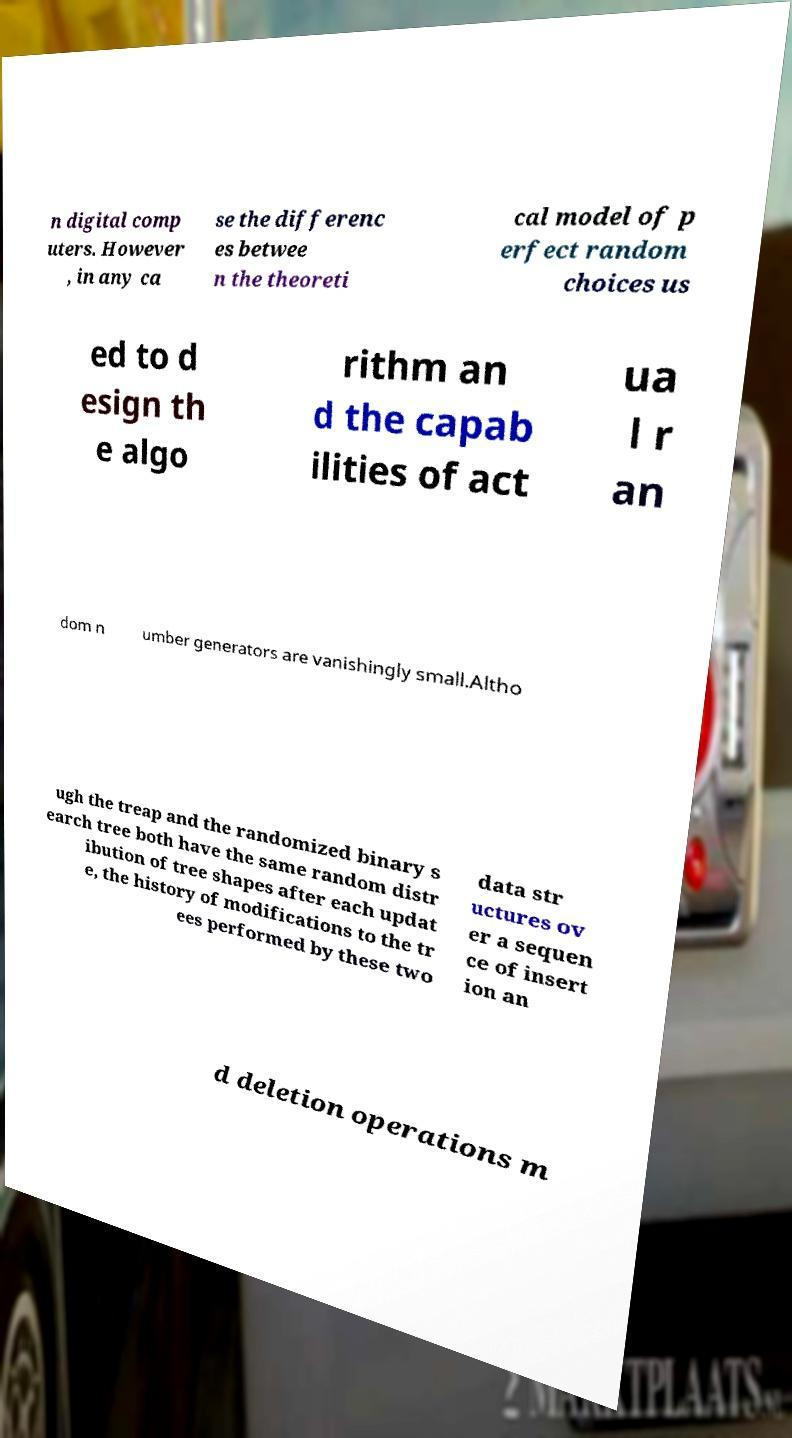Can you read and provide the text displayed in the image?This photo seems to have some interesting text. Can you extract and type it out for me? n digital comp uters. However , in any ca se the differenc es betwee n the theoreti cal model of p erfect random choices us ed to d esign th e algo rithm an d the capab ilities of act ua l r an dom n umber generators are vanishingly small.Altho ugh the treap and the randomized binary s earch tree both have the same random distr ibution of tree shapes after each updat e, the history of modifications to the tr ees performed by these two data str uctures ov er a sequen ce of insert ion an d deletion operations m 